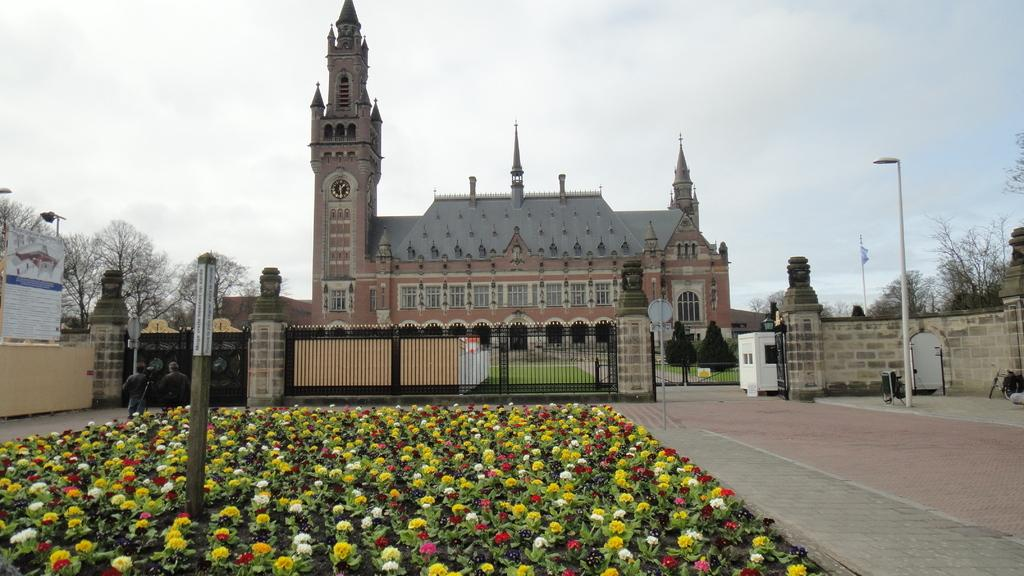What type of plants can be seen in the image? There are flowers in the image. What type of structure is present in the image? There is fencing in the image. What other natural elements can be seen in the image? There are trees in the image. What type of lighting is visible in the image? Street lights are visible in the image. Where is the flag located in the image? There is a flag on the right side of the image. What type of building is present in the image? There is a building in the image. What feature is present on the building? A clock is present on the building. What advice is the bat giving to the flowers in the image? There is no bat present in the image, and therefore no such interaction can be observed. What type of road is visible in the image? There is no road visible in the image. 